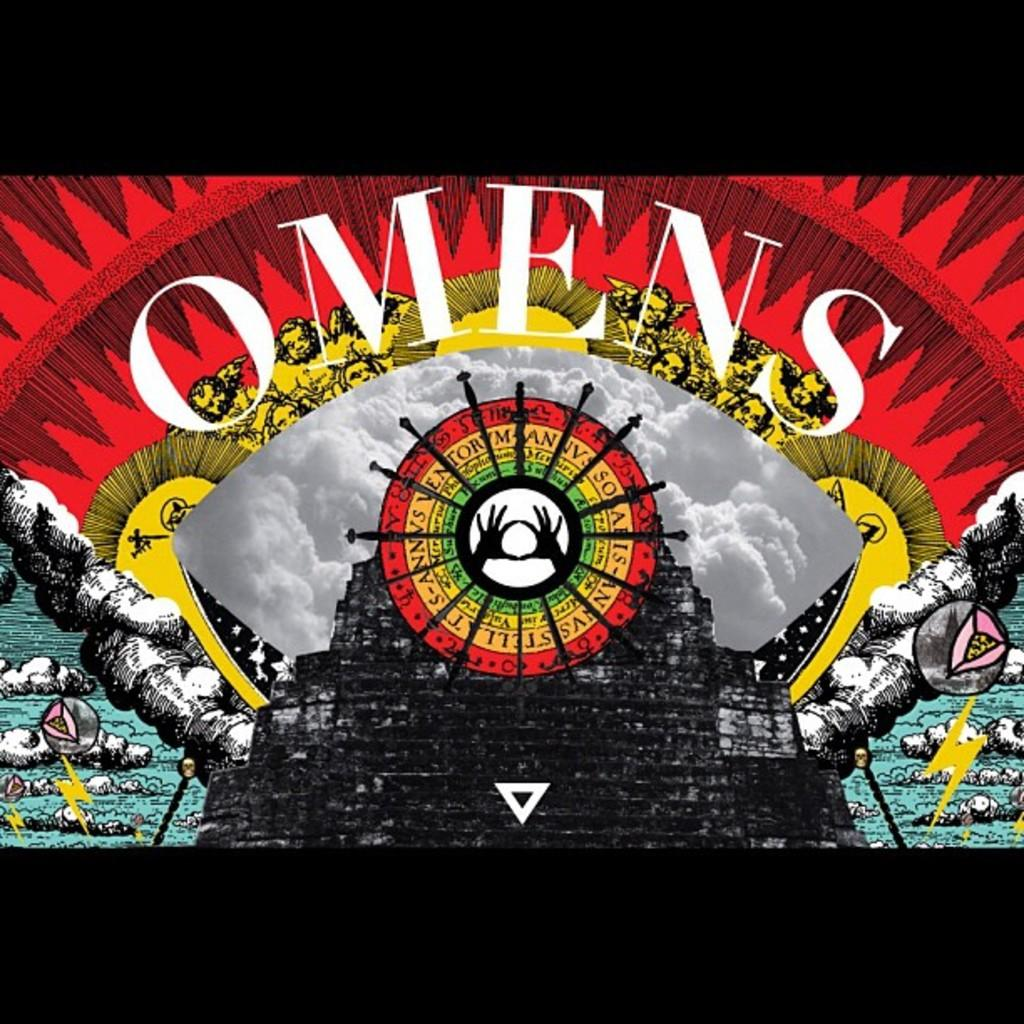<image>
Share a concise interpretation of the image provided. colorful poster with white OMENS on it  and circle with hands in middle 